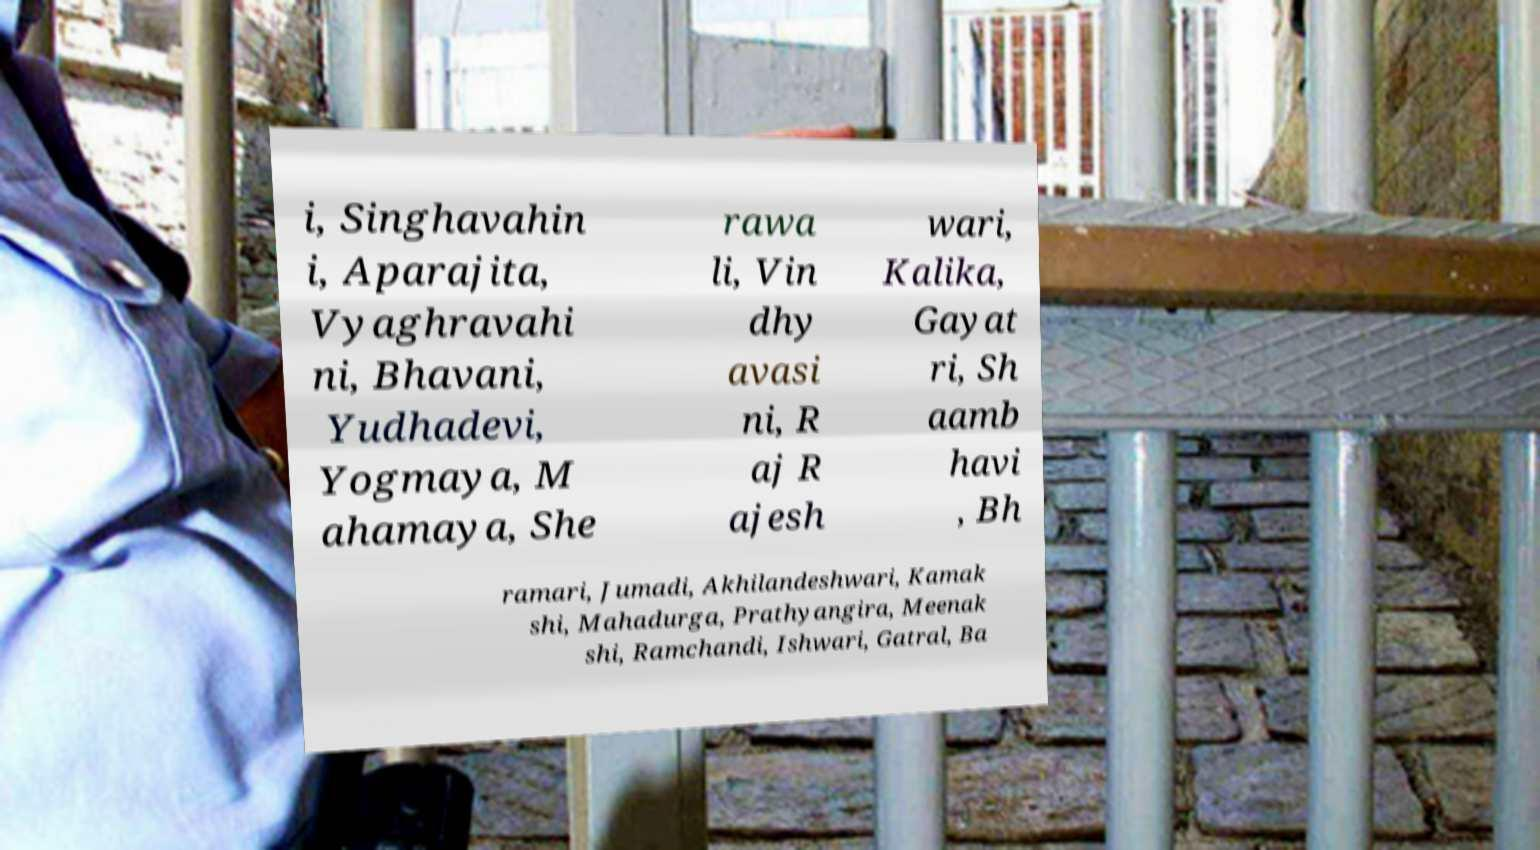I need the written content from this picture converted into text. Can you do that? i, Singhavahin i, Aparajita, Vyaghravahi ni, Bhavani, Yudhadevi, Yogmaya, M ahamaya, She rawa li, Vin dhy avasi ni, R aj R ajesh wari, Kalika, Gayat ri, Sh aamb havi , Bh ramari, Jumadi, Akhilandeshwari, Kamak shi, Mahadurga, Prathyangira, Meenak shi, Ramchandi, Ishwari, Gatral, Ba 